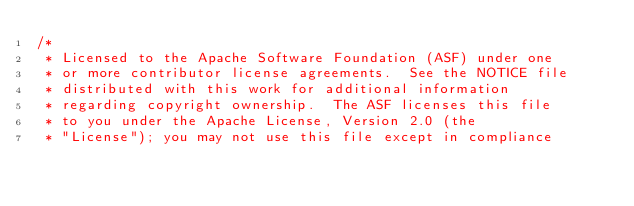Convert code to text. <code><loc_0><loc_0><loc_500><loc_500><_Java_>/*
 * Licensed to the Apache Software Foundation (ASF) under one
 * or more contributor license agreements.  See the NOTICE file
 * distributed with this work for additional information
 * regarding copyright ownership.  The ASF licenses this file
 * to you under the Apache License, Version 2.0 (the
 * "License"); you may not use this file except in compliance</code> 